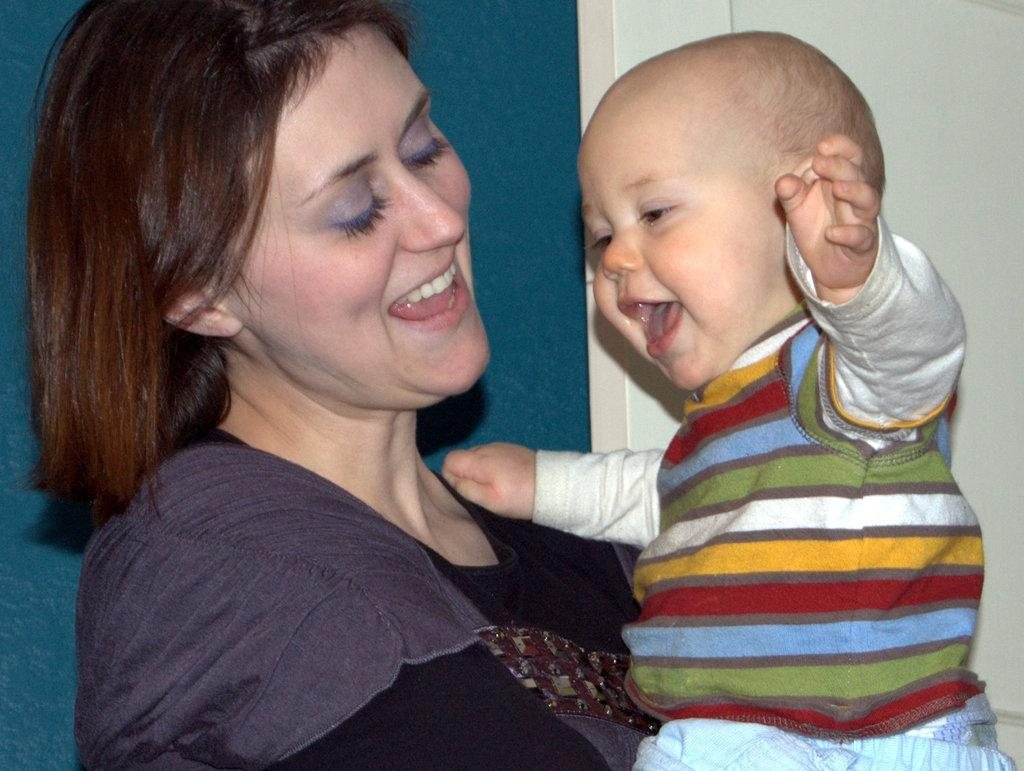Who is the main subject in the image? There is a woman in the image. What is the woman wearing? The woman is wearing a black dress. What is the woman holding in the image? The woman is holding a baby boy. Can you describe the baby boy's outfit? The baby boy is wearing a sweater, t-shirt, and shorts. Where is the woman standing in the image? The woman is standing near a window and a wall. What type of board can be seen in the image? There is no board present in the image. Is the baby boy swinging in the image? No, the baby boy is not swinging in the image; he is being held by the woman. 